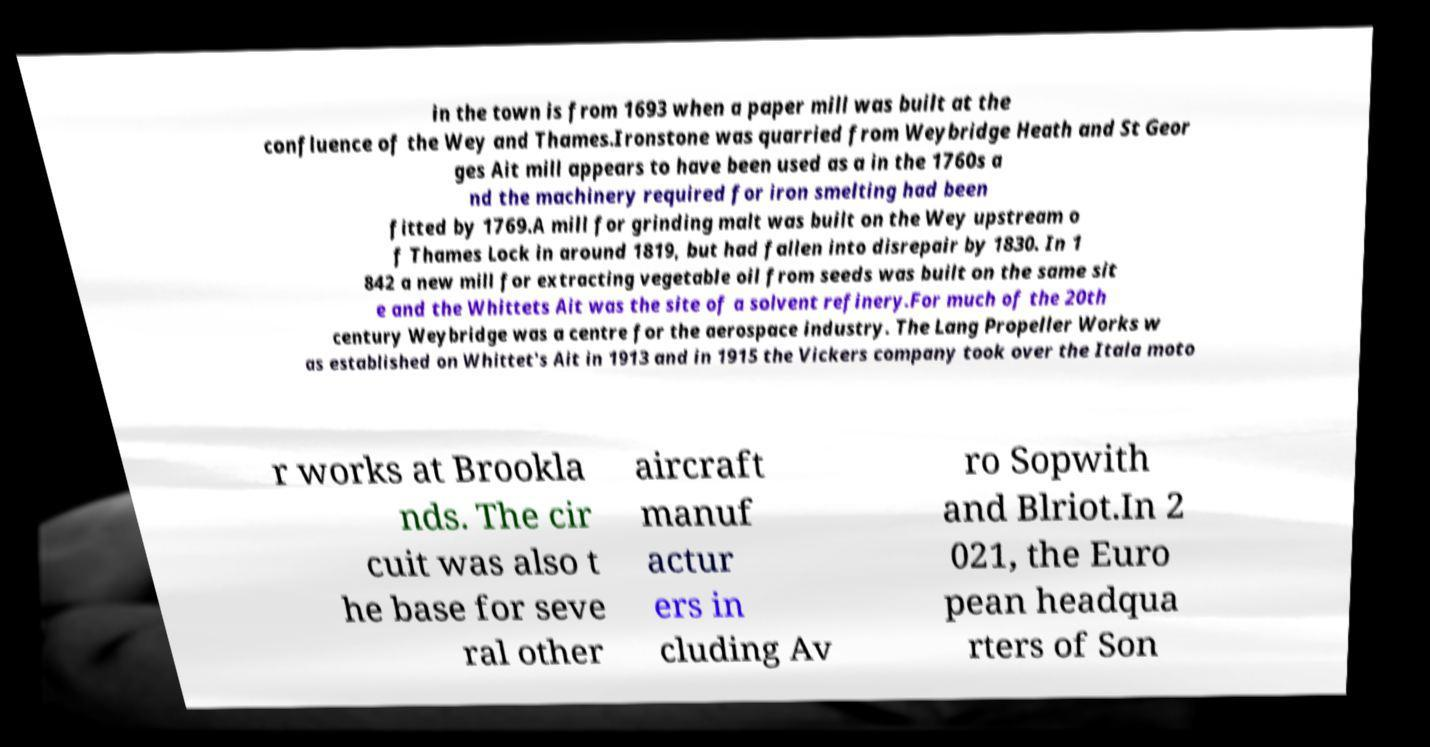I need the written content from this picture converted into text. Can you do that? in the town is from 1693 when a paper mill was built at the confluence of the Wey and Thames.Ironstone was quarried from Weybridge Heath and St Geor ges Ait mill appears to have been used as a in the 1760s a nd the machinery required for iron smelting had been fitted by 1769.A mill for grinding malt was built on the Wey upstream o f Thames Lock in around 1819, but had fallen into disrepair by 1830. In 1 842 a new mill for extracting vegetable oil from seeds was built on the same sit e and the Whittets Ait was the site of a solvent refinery.For much of the 20th century Weybridge was a centre for the aerospace industry. The Lang Propeller Works w as established on Whittet's Ait in 1913 and in 1915 the Vickers company took over the Itala moto r works at Brookla nds. The cir cuit was also t he base for seve ral other aircraft manuf actur ers in cluding Av ro Sopwith and Blriot.In 2 021, the Euro pean headqua rters of Son 